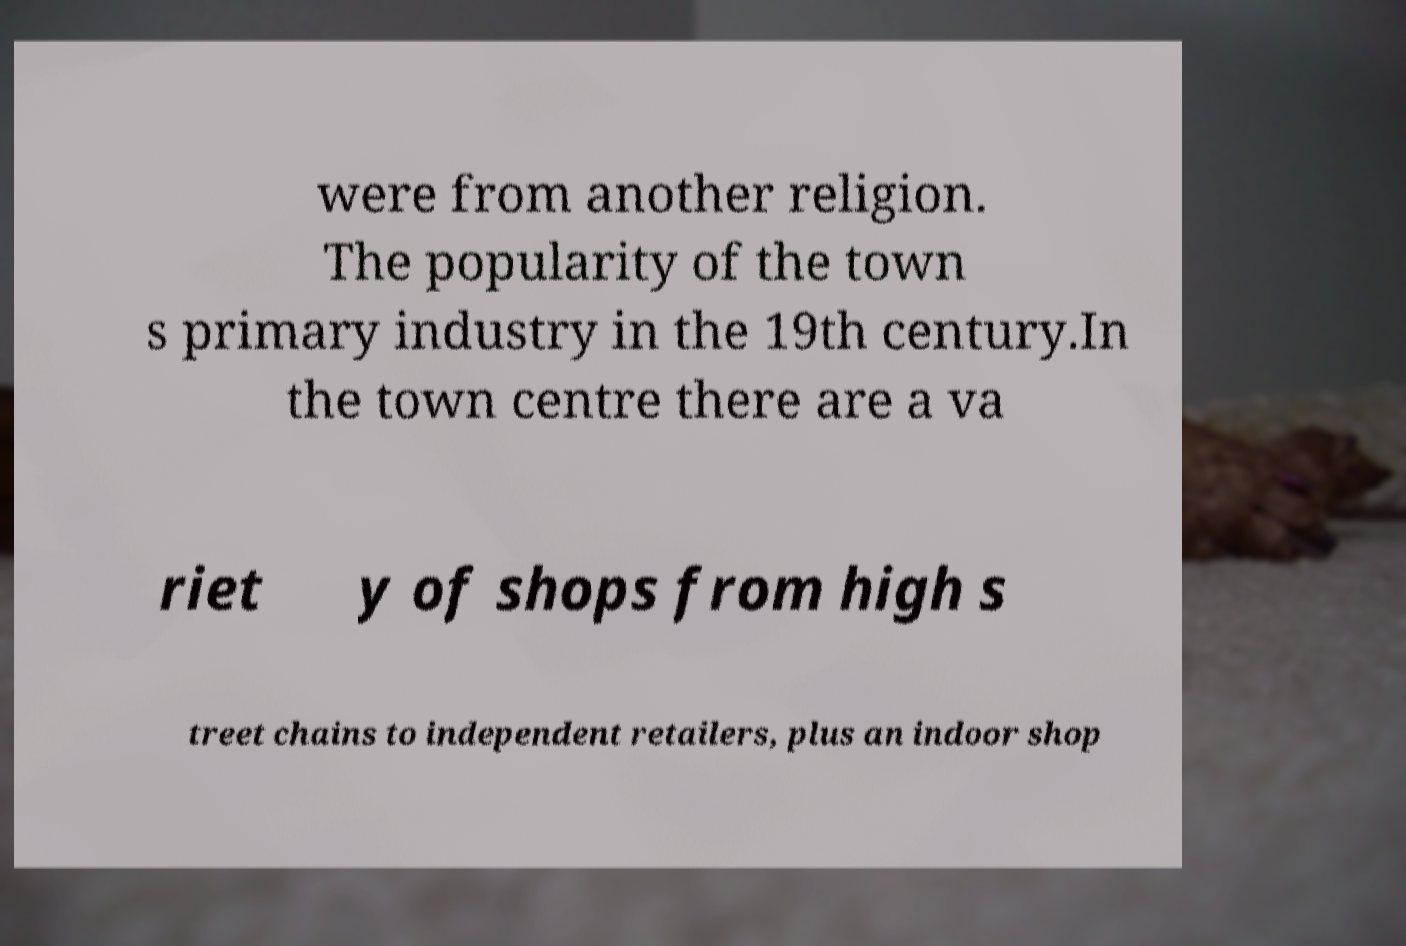Could you assist in decoding the text presented in this image and type it out clearly? were from another religion. The popularity of the town s primary industry in the 19th century.In the town centre there are a va riet y of shops from high s treet chains to independent retailers, plus an indoor shop 